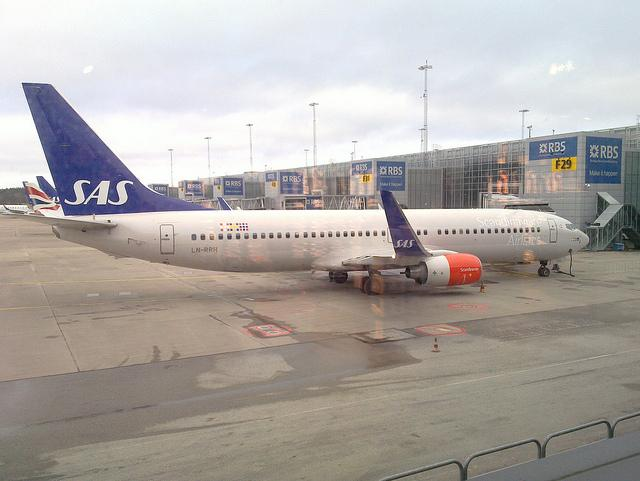What country is served by this airline? sweden 